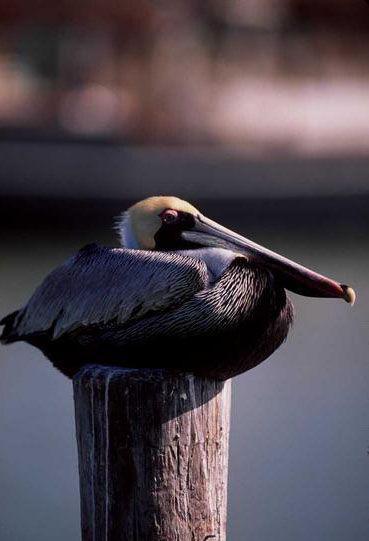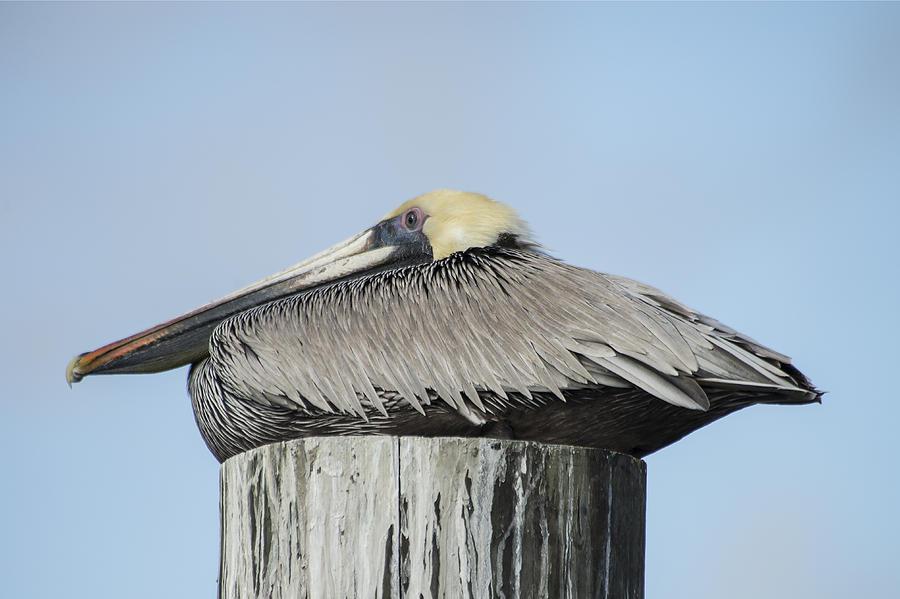The first image is the image on the left, the second image is the image on the right. Considering the images on both sides, is "Each image contains exactly one pelican, and all pelicans have a flattened pose with bill resting on breast." valid? Answer yes or no. Yes. The first image is the image on the left, the second image is the image on the right. Evaluate the accuracy of this statement regarding the images: "There is a bird facing towards the left in the left image.". Is it true? Answer yes or no. No. 